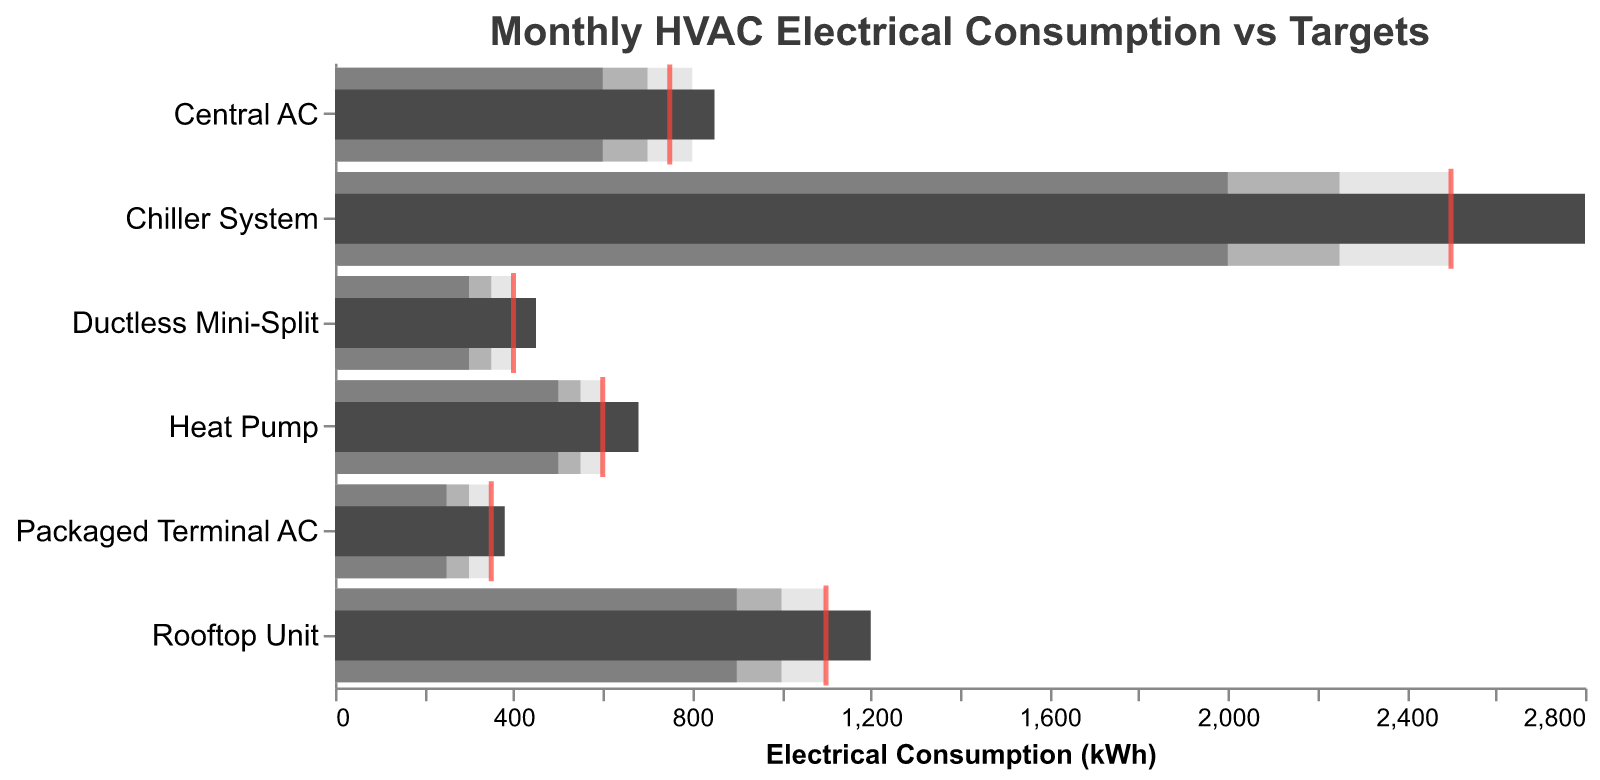What's the title of the figure? The title is located at the top of the figure. It reads "Monthly HVAC Electrical Consumption vs Targets" according to the provided data and code.
Answer: Monthly HVAC Electrical Consumption vs Targets Which HVAC unit has the highest actual electrical consumption? Looking at the "Actual" bar (dark gray) for each HVAC unit, the "Chiller System" has the highest value at 2800 kWh.
Answer: Chiller System How does the actual consumption of the Central AC compare to its target? The Central AC has an "Actual" bar at 850 kWh and a target indicated by a red tick mark at 750 kWh. The actual value exceeds the target by 100 kWh.
Answer: 100 kWh more Which HVAC unit is closest to its energy-saving target? The closest match between the dark gray bar (actual) and the red tick (target) is the Ductless Mini-Split, with an actual value of 450 kWh compared to a target of 400 kWh, a difference of 50 kWh.
Answer: Ductless Mini-Split Which HVAC unit is furthest from its target? The Chiller System has the largest discrepancy with an actual value of 2800 kWh and a target of 2500 kWh, a difference of 300 kWh.
Answer: Chiller System What is the range of acceptable electrical consumption for the Rooftop Unit? The ranges for the Rooftop Unit are provided in three shades: 900-1100 kWh.
Answer: 900-1100 kWh How many HVAC units have actual consumption greater than their targets? By comparing the dark gray bars with their corresponding red ticks, Central AC, Heat Pump, Rooftop Unit, Chiller System, and Packaged Terminal AC all have higher actual values than their targets.
Answer: 5 units Compare the actual consumption of the Heat Pump to the Central AC. The Heat Pump has an actual consumption of 680 kWh, while the Central AC has 850 kWh. The Heat Pump consumes 170 kWh less than the Central AC.
Answer: Heat Pump consumes 170 kWh less What is the total target electrical consumption for all HVAC units combined? Summing up the target values: 750 (Central AC) + 600 (Heat Pump) + 400 (Ductless Mini-Split) + 1100 (Rooftop Unit) + 2500 (Chiller System) + 350 (Packaged Terminal AC) = 5700 kWh.
Answer: 5700 kWh What is the average actual electrical consumption among the HVAC units? Summing up the actual values and dividing by the number of units: (850 + 680 + 450 + 1200 + 2800 + 380) / 6 = 7360 / 6 ≈ 1227 kWh.
Answer: ≈1227 kWh 